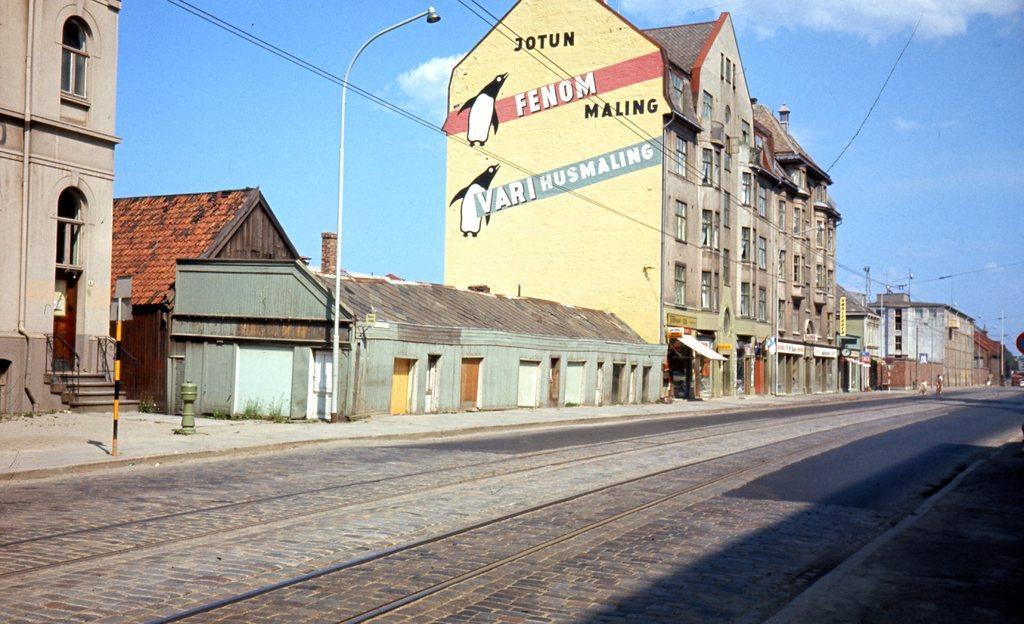Describe this image in one or two sentences. In the picture we can see some railway tracks on the path and beside to it, we can see some poles, street lights and some houses, buildings with a window and sky with clouds. 